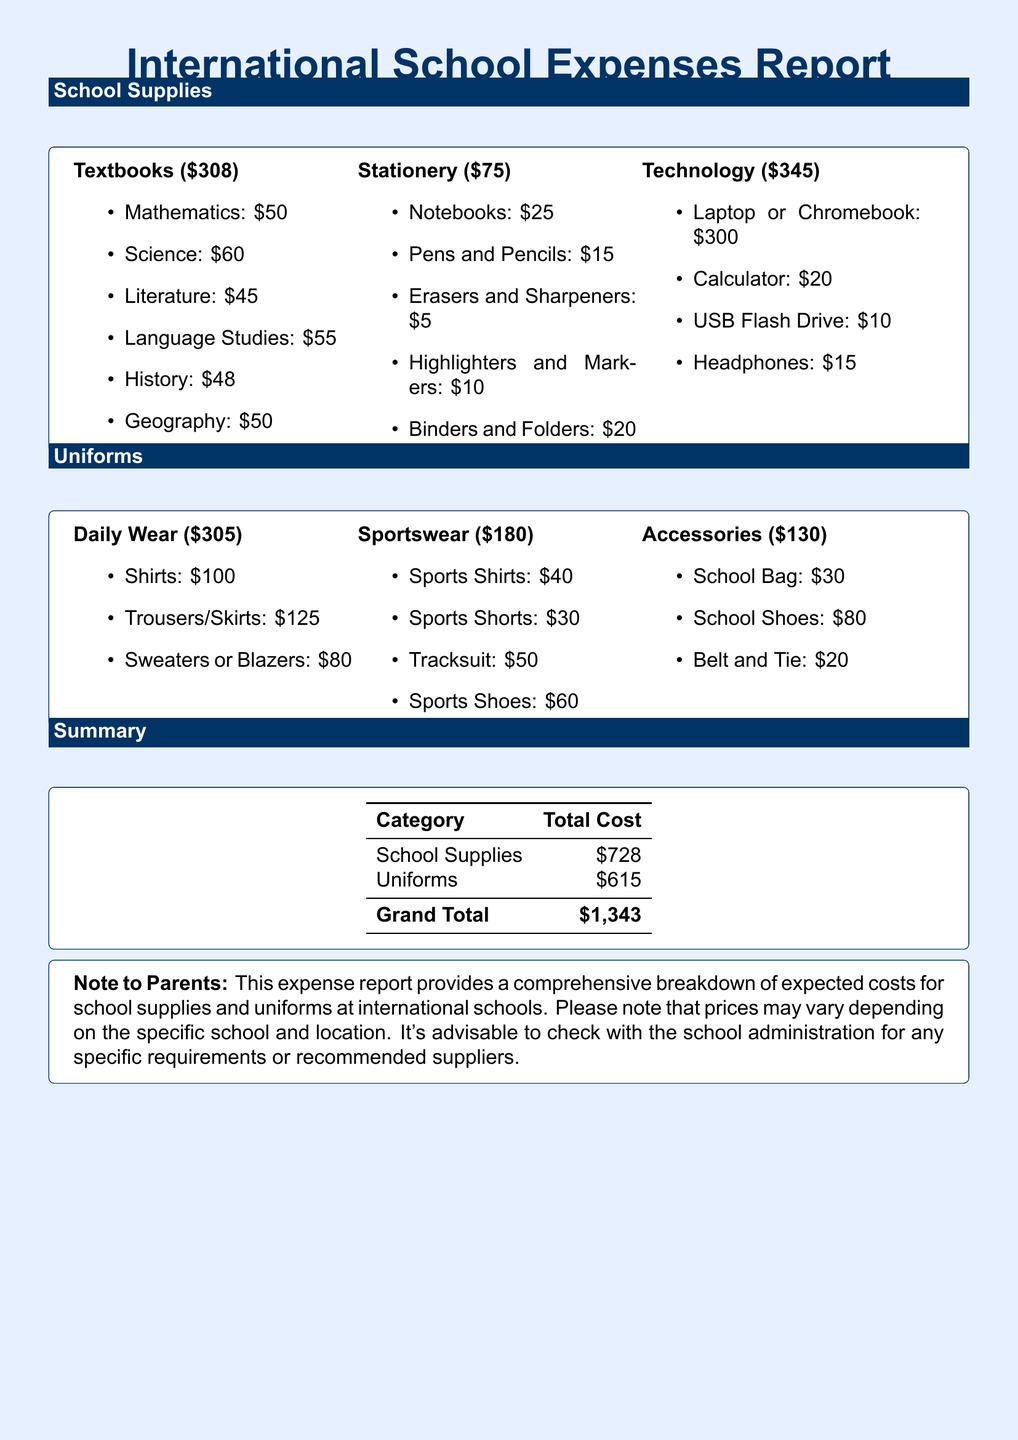what is the total cost for school supplies? The total cost for school supplies is listed in the summary section of the document as $728.
Answer: $728 what is the total cost for uniforms? The total cost for uniforms is included in the summary section of the document as $615.
Answer: $615 what is the grand total of expenses? The grand total is calculated in the summary section, combining both school supplies and uniforms as $1,343.
Answer: $1,343 how much do textbooks cost? Textbooks in the school supplies section are itemized with a total cost of $308.
Answer: $308 what is the cost of technology supplies? Technology costs are specified in the school supplies section as totaling $345.
Answer: $345 what is the cost of daily wear uniforms? The total cost for daily wear uniforms is provided in the uniforms section as $305.
Answer: $305 how much do sportswear items cost in total? Sportswear total is mentioned in the uniforms section as $180, summarizing the cost of all sports items.
Answer: $180 what is the total cost of accessories? Accessories are outlined in the uniforms section with a total cost of $130.
Answer: $130 what is the price of the laptop or Chromebook? The document lists the cost of a laptop or Chromebook as $300 under technology supplies.
Answer: $300 